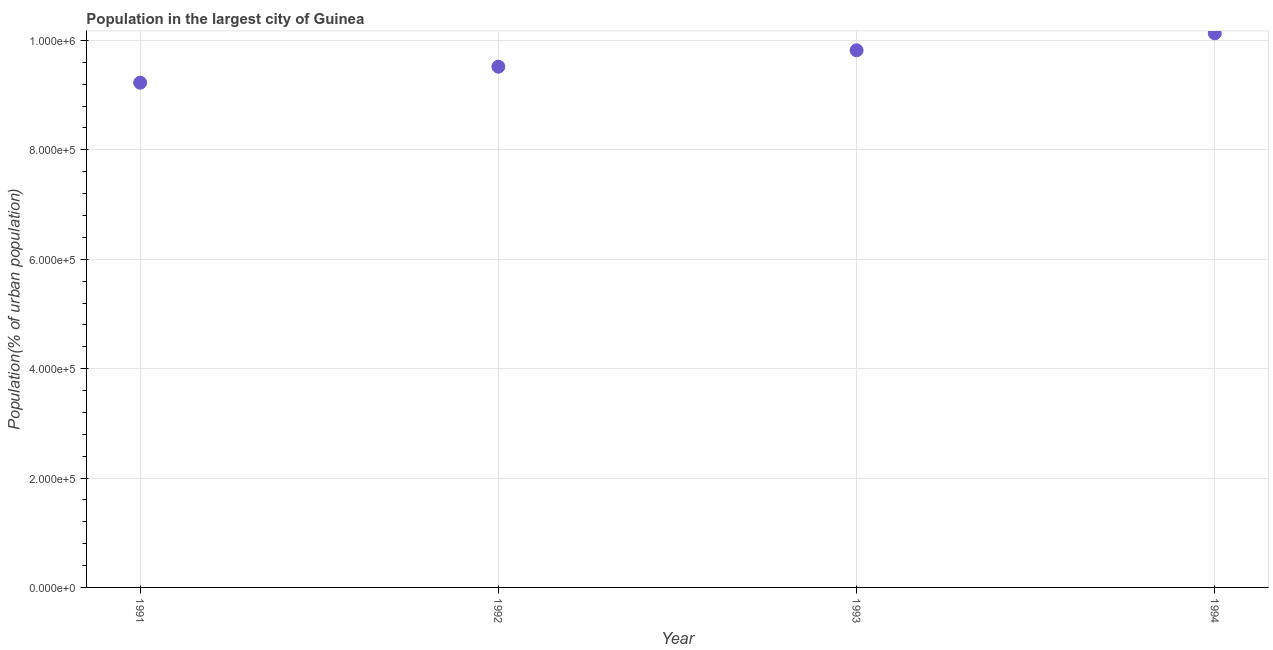What is the population in largest city in 1994?
Your answer should be compact. 1.01e+06. Across all years, what is the maximum population in largest city?
Give a very brief answer. 1.01e+06. Across all years, what is the minimum population in largest city?
Give a very brief answer. 9.23e+05. In which year was the population in largest city maximum?
Your answer should be compact. 1994. What is the sum of the population in largest city?
Provide a succinct answer. 3.87e+06. What is the difference between the population in largest city in 1991 and 1992?
Provide a short and direct response. -2.92e+04. What is the average population in largest city per year?
Your answer should be very brief. 9.68e+05. What is the median population in largest city?
Offer a very short reply. 9.67e+05. In how many years, is the population in largest city greater than 720000 %?
Offer a very short reply. 4. Do a majority of the years between 1991 and 1994 (inclusive) have population in largest city greater than 360000 %?
Ensure brevity in your answer.  Yes. What is the ratio of the population in largest city in 1993 to that in 1994?
Offer a very short reply. 0.97. Is the population in largest city in 1991 less than that in 1993?
Give a very brief answer. Yes. What is the difference between the highest and the second highest population in largest city?
Your answer should be compact. 3.10e+04. Is the sum of the population in largest city in 1991 and 1992 greater than the maximum population in largest city across all years?
Provide a succinct answer. Yes. What is the difference between the highest and the lowest population in largest city?
Ensure brevity in your answer.  9.03e+04. Does the population in largest city monotonically increase over the years?
Your response must be concise. Yes. How many dotlines are there?
Offer a terse response. 1. How many years are there in the graph?
Offer a terse response. 4. Are the values on the major ticks of Y-axis written in scientific E-notation?
Offer a terse response. Yes. Does the graph contain any zero values?
Your answer should be very brief. No. What is the title of the graph?
Make the answer very short. Population in the largest city of Guinea. What is the label or title of the X-axis?
Make the answer very short. Year. What is the label or title of the Y-axis?
Offer a very short reply. Population(% of urban population). What is the Population(% of urban population) in 1991?
Make the answer very short. 9.23e+05. What is the Population(% of urban population) in 1992?
Provide a short and direct response. 9.52e+05. What is the Population(% of urban population) in 1993?
Provide a short and direct response. 9.82e+05. What is the Population(% of urban population) in 1994?
Provide a succinct answer. 1.01e+06. What is the difference between the Population(% of urban population) in 1991 and 1992?
Provide a succinct answer. -2.92e+04. What is the difference between the Population(% of urban population) in 1991 and 1993?
Your answer should be compact. -5.92e+04. What is the difference between the Population(% of urban population) in 1991 and 1994?
Give a very brief answer. -9.03e+04. What is the difference between the Population(% of urban population) in 1992 and 1993?
Give a very brief answer. -3.00e+04. What is the difference between the Population(% of urban population) in 1992 and 1994?
Provide a short and direct response. -6.11e+04. What is the difference between the Population(% of urban population) in 1993 and 1994?
Your answer should be compact. -3.10e+04. What is the ratio of the Population(% of urban population) in 1991 to that in 1993?
Provide a succinct answer. 0.94. What is the ratio of the Population(% of urban population) in 1991 to that in 1994?
Ensure brevity in your answer.  0.91. What is the ratio of the Population(% of urban population) in 1992 to that in 1994?
Offer a very short reply. 0.94. 